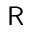<formula> <loc_0><loc_0><loc_500><loc_500>R</formula> 